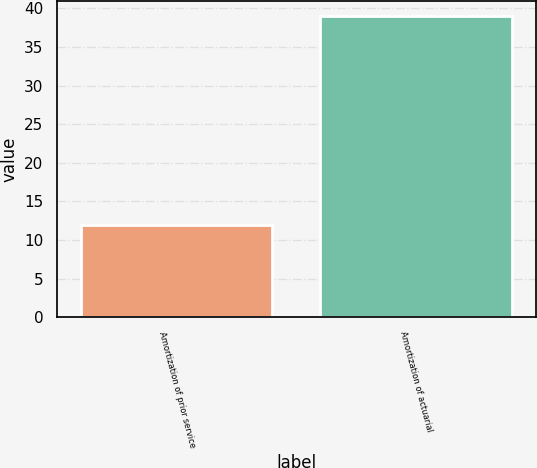<chart> <loc_0><loc_0><loc_500><loc_500><bar_chart><fcel>Amortization of prior service<fcel>Amortization of actuarial<nl><fcel>12<fcel>39<nl></chart> 